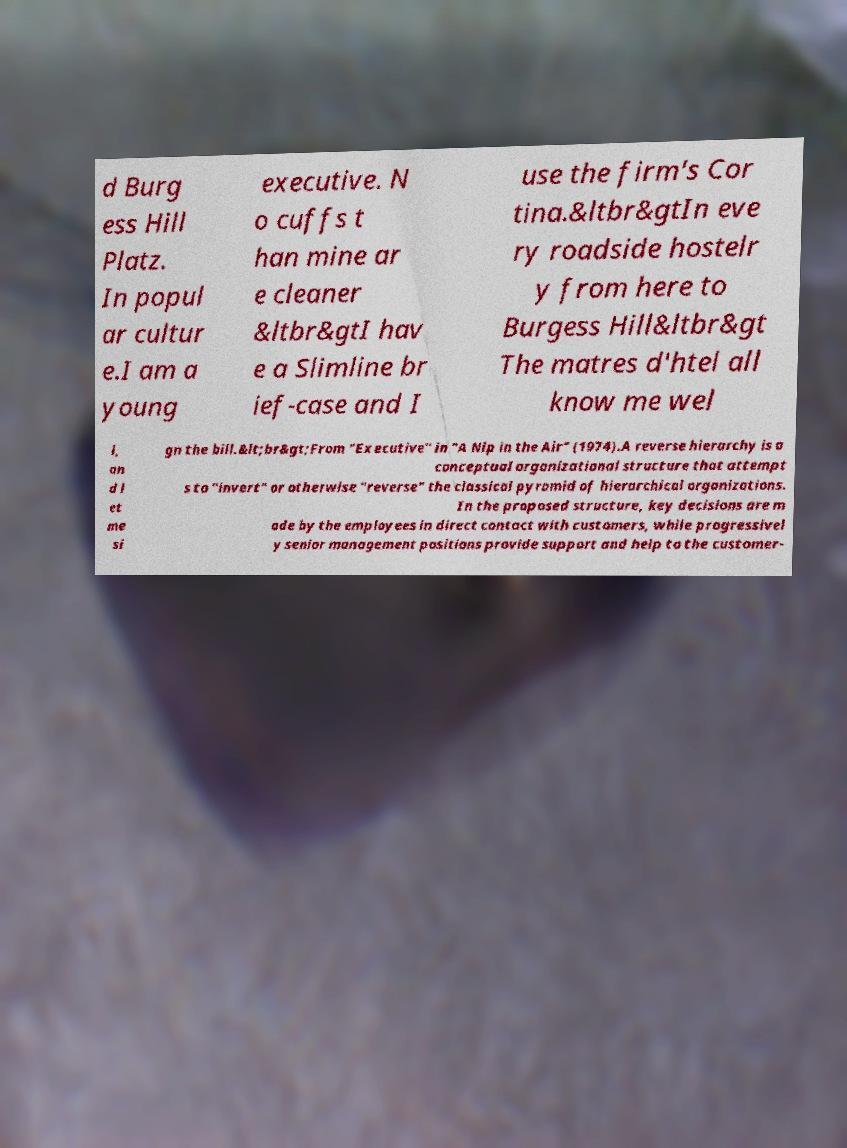What messages or text are displayed in this image? I need them in a readable, typed format. d Burg ess Hill Platz. In popul ar cultur e.I am a young executive. N o cuffs t han mine ar e cleaner &ltbr&gtI hav e a Slimline br ief-case and I use the firm's Cor tina.&ltbr&gtIn eve ry roadside hostelr y from here to Burgess Hill&ltbr&gt The matres d'htel all know me wel l, an d l et me si gn the bill.&lt;br&gt;From "Executive" in "A Nip in the Air" (1974).A reverse hierarchy is a conceptual organizational structure that attempt s to "invert" or otherwise "reverse" the classical pyramid of hierarchical organizations. In the proposed structure, key decisions are m ade by the employees in direct contact with customers, while progressivel y senior management positions provide support and help to the customer- 